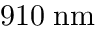<formula> <loc_0><loc_0><loc_500><loc_500>9 1 0 \, n m</formula> 